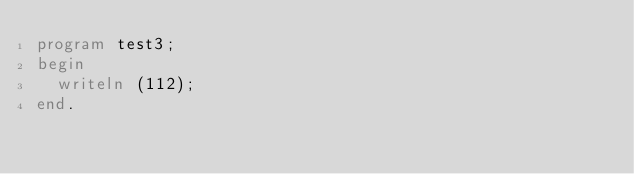Convert code to text. <code><loc_0><loc_0><loc_500><loc_500><_Pascal_>program test3;
begin
  writeln (112);
end.

</code> 